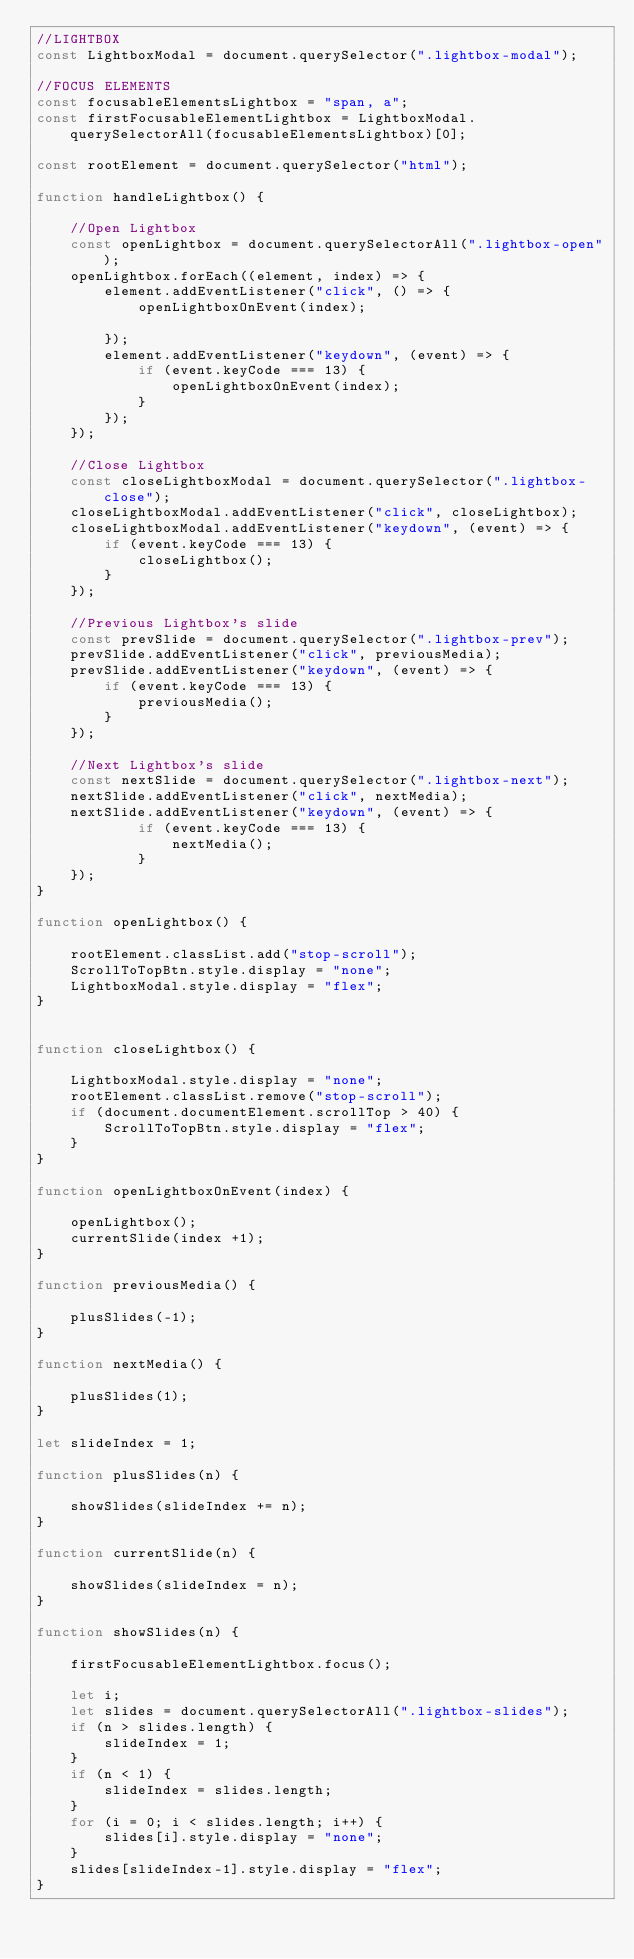Convert code to text. <code><loc_0><loc_0><loc_500><loc_500><_JavaScript_>//LIGHTBOX
const LightboxModal = document.querySelector(".lightbox-modal");

//FOCUS ELEMENTS
const focusableElementsLightbox = "span, a";
const firstFocusableElementLightbox = LightboxModal.querySelectorAll(focusableElementsLightbox)[0];

const rootElement = document.querySelector("html");

function handleLightbox() {

    //Open Lightbox
    const openLightbox = document.querySelectorAll(".lightbox-open");
    openLightbox.forEach((element, index) => {
        element.addEventListener("click", () => {
            openLightboxOnEvent(index);

        });
        element.addEventListener("keydown", (event) => {
            if (event.keyCode === 13) {
                openLightboxOnEvent(index);
            }
        });
    });

    //Close Lightbox
    const closeLightboxModal = document.querySelector(".lightbox-close");
    closeLightboxModal.addEventListener("click", closeLightbox);
    closeLightboxModal.addEventListener("keydown", (event) => {
        if (event.keyCode === 13) {
            closeLightbox();
        }
    });

    //Previous Lightbox's slide
    const prevSlide = document.querySelector(".lightbox-prev");
    prevSlide.addEventListener("click", previousMedia);
    prevSlide.addEventListener("keydown", (event) => {
        if (event.keyCode === 13) {
            previousMedia();
        }
    });

    //Next Lightbox's slide
    const nextSlide = document.querySelector(".lightbox-next");
    nextSlide.addEventListener("click", nextMedia);
    nextSlide.addEventListener("keydown", (event) => {
            if (event.keyCode === 13) {
                nextMedia();
            }
    });
}

function openLightbox() {

    rootElement.classList.add("stop-scroll");
    ScrollToTopBtn.style.display = "none";
    LightboxModal.style.display = "flex";
}


function closeLightbox() {

    LightboxModal.style.display = "none";
    rootElement.classList.remove("stop-scroll");
    if (document.documentElement.scrollTop > 40) {
        ScrollToTopBtn.style.display = "flex";
    }
}

function openLightboxOnEvent(index) {

    openLightbox();
    currentSlide(index +1);
}

function previousMedia() {

    plusSlides(-1);
}

function nextMedia() {

    plusSlides(1);
}

let slideIndex = 1;

function plusSlides(n) {

    showSlides(slideIndex += n);
}

function currentSlide(n) {

    showSlides(slideIndex = n);
}

function showSlides(n) {

    firstFocusableElementLightbox.focus();

    let i;
    let slides = document.querySelectorAll(".lightbox-slides");
    if (n > slides.length) {
        slideIndex = 1;
    }
    if (n < 1) {
        slideIndex = slides.length;
    }
    for (i = 0; i < slides.length; i++) {
        slides[i].style.display = "none";
    }
    slides[slideIndex-1].style.display = "flex";
}</code> 